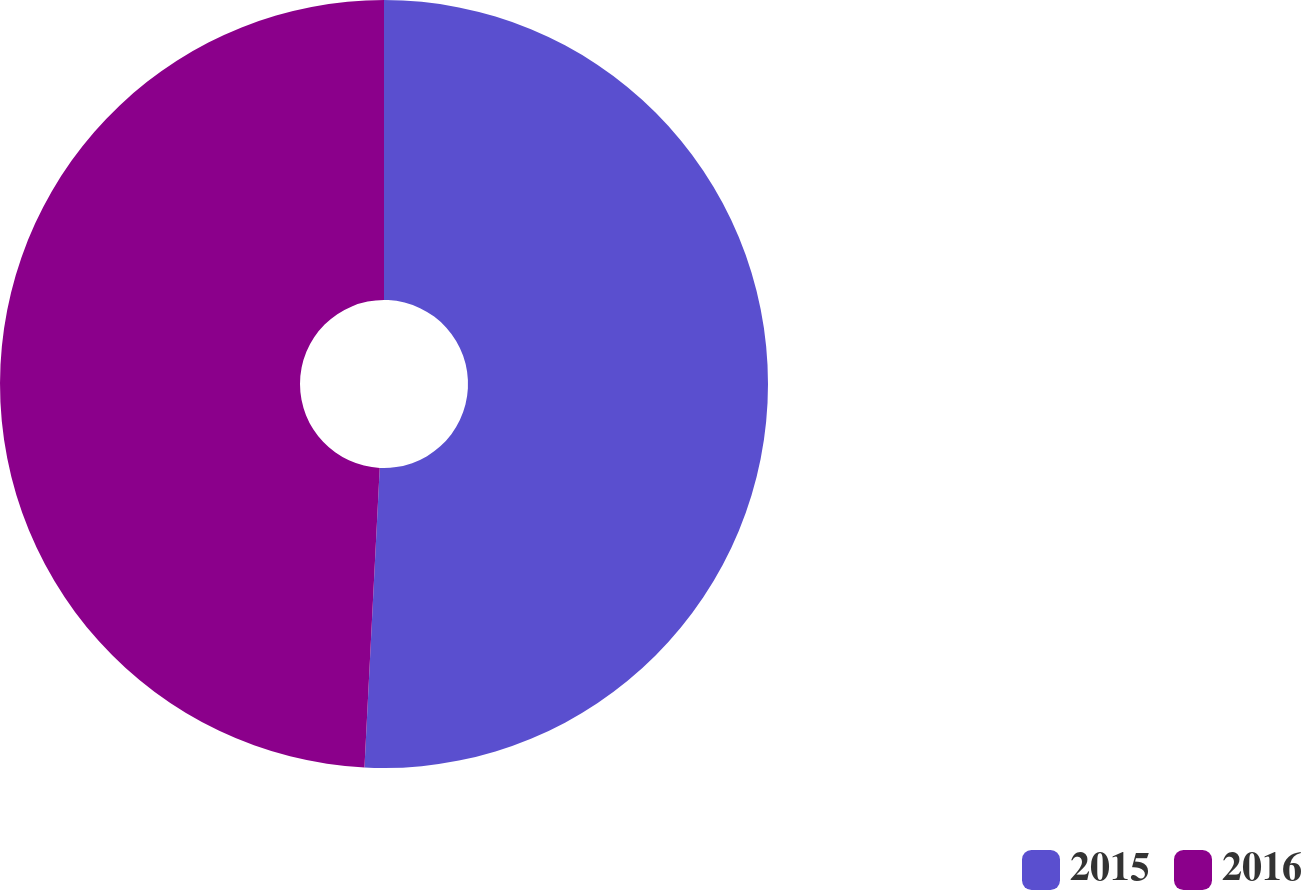Convert chart. <chart><loc_0><loc_0><loc_500><loc_500><pie_chart><fcel>2015<fcel>2016<nl><fcel>50.81%<fcel>49.19%<nl></chart> 